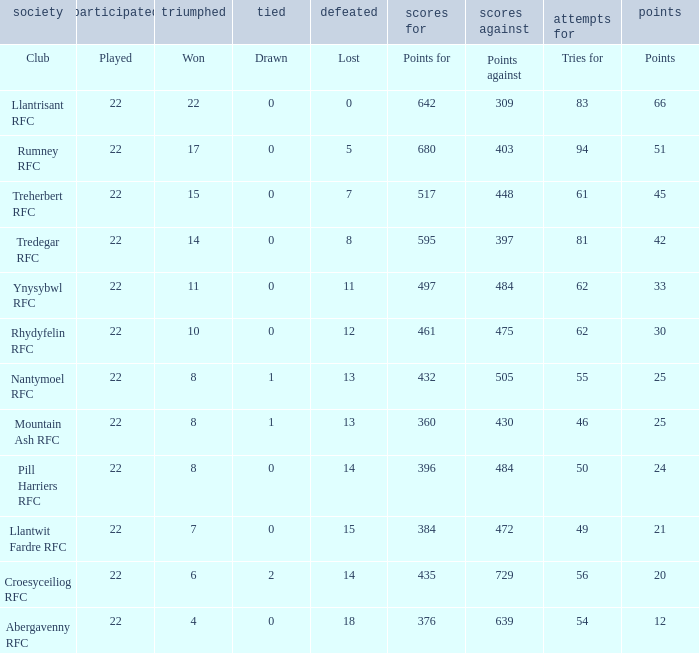How many tries for were scored by the team that had exactly 396 points for? 50.0. 